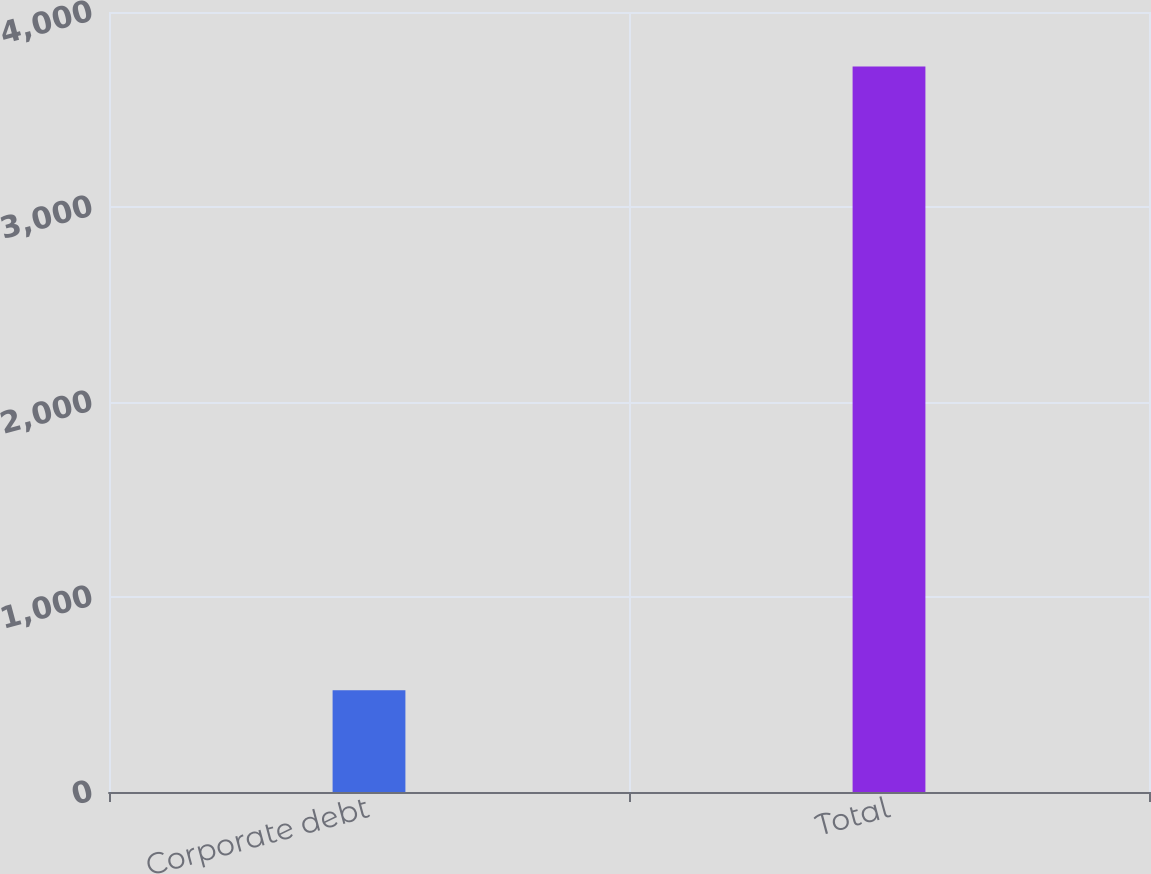<chart> <loc_0><loc_0><loc_500><loc_500><bar_chart><fcel>Corporate debt<fcel>Total<nl><fcel>522<fcel>3721<nl></chart> 